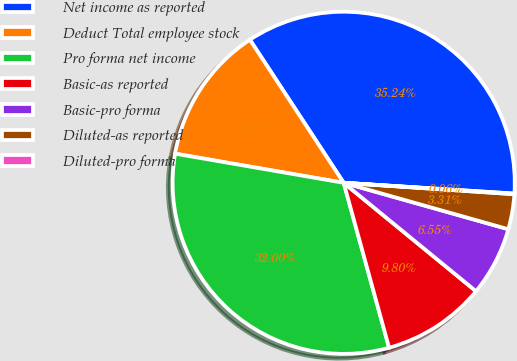<chart> <loc_0><loc_0><loc_500><loc_500><pie_chart><fcel>Net income as reported<fcel>Deduct Total employee stock<fcel>Pro forma net income<fcel>Basic-as reported<fcel>Basic-pro forma<fcel>Diluted-as reported<fcel>Diluted-pro forma<nl><fcel>35.24%<fcel>13.04%<fcel>32.0%<fcel>9.8%<fcel>6.55%<fcel>3.31%<fcel>0.06%<nl></chart> 